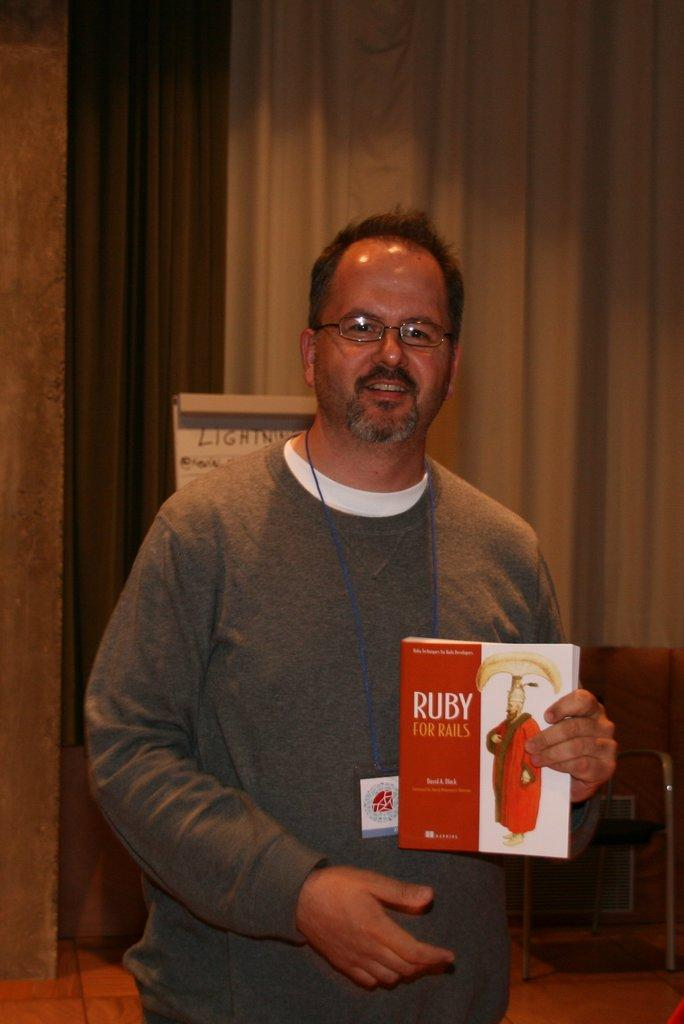<image>
Share a concise interpretation of the image provided. A man holds a textbook on the coding language Ruby. 